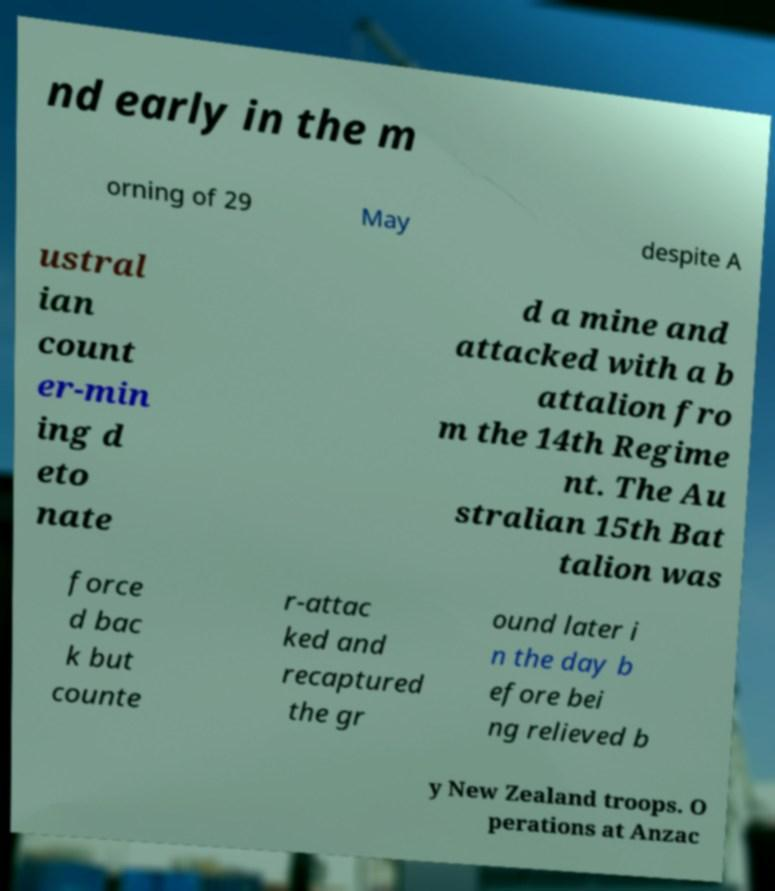Can you read and provide the text displayed in the image?This photo seems to have some interesting text. Can you extract and type it out for me? nd early in the m orning of 29 May despite A ustral ian count er-min ing d eto nate d a mine and attacked with a b attalion fro m the 14th Regime nt. The Au stralian 15th Bat talion was force d bac k but counte r-attac ked and recaptured the gr ound later i n the day b efore bei ng relieved b y New Zealand troops. O perations at Anzac 